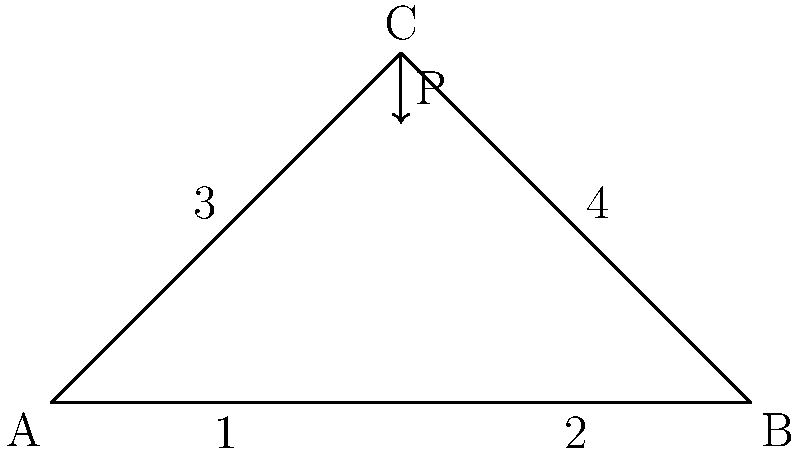A simple truss bridge is shown above, with a load P applied at joint C. Assuming the truss is symmetrical and the load is vertical, which member(s) of the truss will experience the highest compressive stress? To determine which member(s) experience the highest compressive stress, we need to analyze the force distribution in the truss:

1. Due to symmetry and the vertical load, the reactions at supports A and B will be equal, each carrying half of the load P.

2. Members 1 and 2 (the bottom chord) will be in tension, as they resist the spreading of supports A and B.

3. Members 3 and 4 (the top chord) will be in compression, as they push against supports A and B to balance the vertical load.

4. The vertical component of the forces in members 3 and 4 must equal the applied load P.

5. The angle between members 3 or 4 and the horizontal is 45° (given the equilateral triangle shape).

6. The compressive force in each of members 3 and 4 can be calculated as:
   $F_{3,4} = \frac{P}{2\sin 45°} = \frac{P}{\sqrt{2}}$

7. Members 3 and 4 will experience equal compressive forces, which are greater than the tensile forces in members 1 and 2.

8. Stress is force divided by area. Assuming all members have the same cross-sectional area, members 3 and 4 will experience the highest compressive stress.
Answer: Members 3 and 4 (the top chord) 